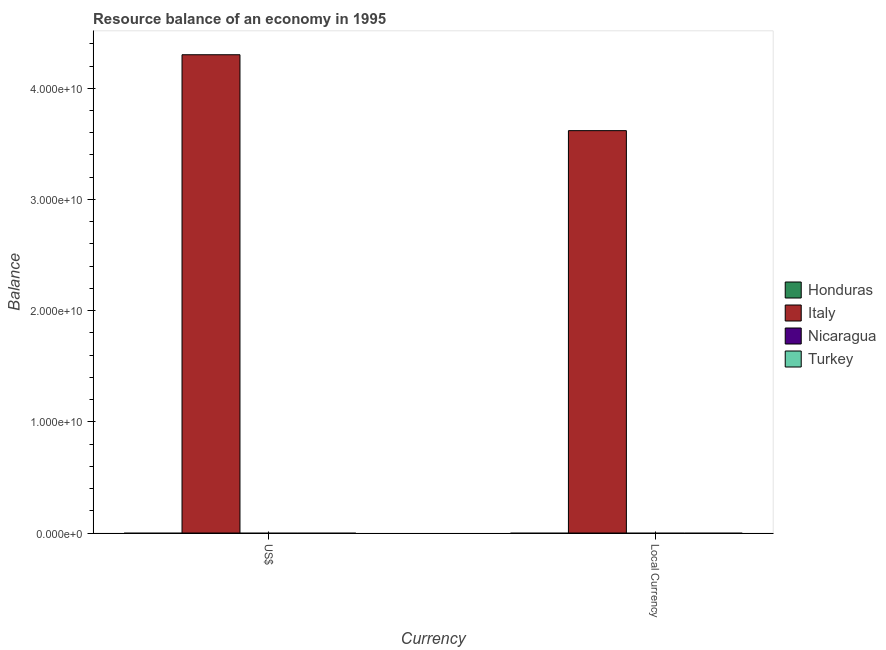How many different coloured bars are there?
Make the answer very short. 1. How many bars are there on the 2nd tick from the left?
Give a very brief answer. 1. What is the label of the 1st group of bars from the left?
Make the answer very short. US$. What is the resource balance in us$ in Turkey?
Give a very brief answer. 0. Across all countries, what is the maximum resource balance in constant us$?
Offer a very short reply. 3.62e+1. In which country was the resource balance in us$ maximum?
Give a very brief answer. Italy. What is the total resource balance in us$ in the graph?
Provide a succinct answer. 4.30e+1. What is the difference between the resource balance in constant us$ in Honduras and the resource balance in us$ in Italy?
Provide a succinct answer. -4.30e+1. What is the average resource balance in constant us$ per country?
Your response must be concise. 9.05e+09. What is the difference between the resource balance in constant us$ and resource balance in us$ in Italy?
Your answer should be compact. -6.83e+09. In how many countries, is the resource balance in us$ greater than the average resource balance in us$ taken over all countries?
Make the answer very short. 1. How many bars are there?
Your answer should be very brief. 2. Are the values on the major ticks of Y-axis written in scientific E-notation?
Keep it short and to the point. Yes. Does the graph contain grids?
Offer a very short reply. No. Where does the legend appear in the graph?
Provide a succinct answer. Center right. What is the title of the graph?
Provide a succinct answer. Resource balance of an economy in 1995. What is the label or title of the X-axis?
Your response must be concise. Currency. What is the label or title of the Y-axis?
Provide a short and direct response. Balance. What is the Balance in Honduras in US$?
Offer a terse response. 0. What is the Balance of Italy in US$?
Your response must be concise. 4.30e+1. What is the Balance in Honduras in Local Currency?
Your answer should be compact. 0. What is the Balance in Italy in Local Currency?
Make the answer very short. 3.62e+1. Across all Currency, what is the maximum Balance in Italy?
Ensure brevity in your answer.  4.30e+1. Across all Currency, what is the minimum Balance in Italy?
Offer a terse response. 3.62e+1. What is the total Balance in Italy in the graph?
Ensure brevity in your answer.  7.92e+1. What is the total Balance of Nicaragua in the graph?
Your response must be concise. 0. What is the difference between the Balance of Italy in US$ and that in Local Currency?
Ensure brevity in your answer.  6.83e+09. What is the average Balance in Italy per Currency?
Your answer should be compact. 3.96e+1. What is the average Balance in Turkey per Currency?
Provide a short and direct response. 0. What is the ratio of the Balance in Italy in US$ to that in Local Currency?
Your answer should be compact. 1.19. What is the difference between the highest and the second highest Balance of Italy?
Provide a short and direct response. 6.83e+09. What is the difference between the highest and the lowest Balance in Italy?
Your answer should be very brief. 6.83e+09. 